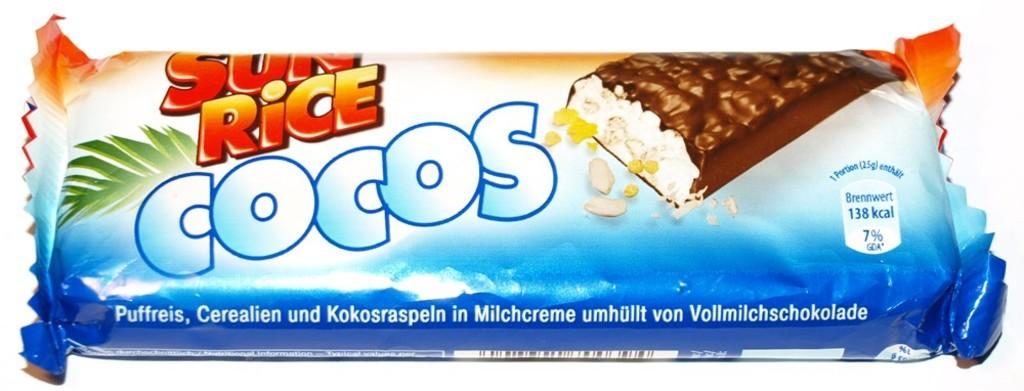What is the main subject of the image? The main subject of the image is a chocolate cover. What can be seen on the chocolate cover? There is some text, a barcode, and pictures on the chocolate cover. What type of jelly can be seen in the image? There is no jelly present in the image. What type of prose is written on the chocolate cover? There is no prose written on the chocolate cover; it contains text, but not prose. What type of fruit is depicted on the chocolate cover? There is no fruit depicted on the chocolate cover; it contains pictures, but not specifically of fruit. 